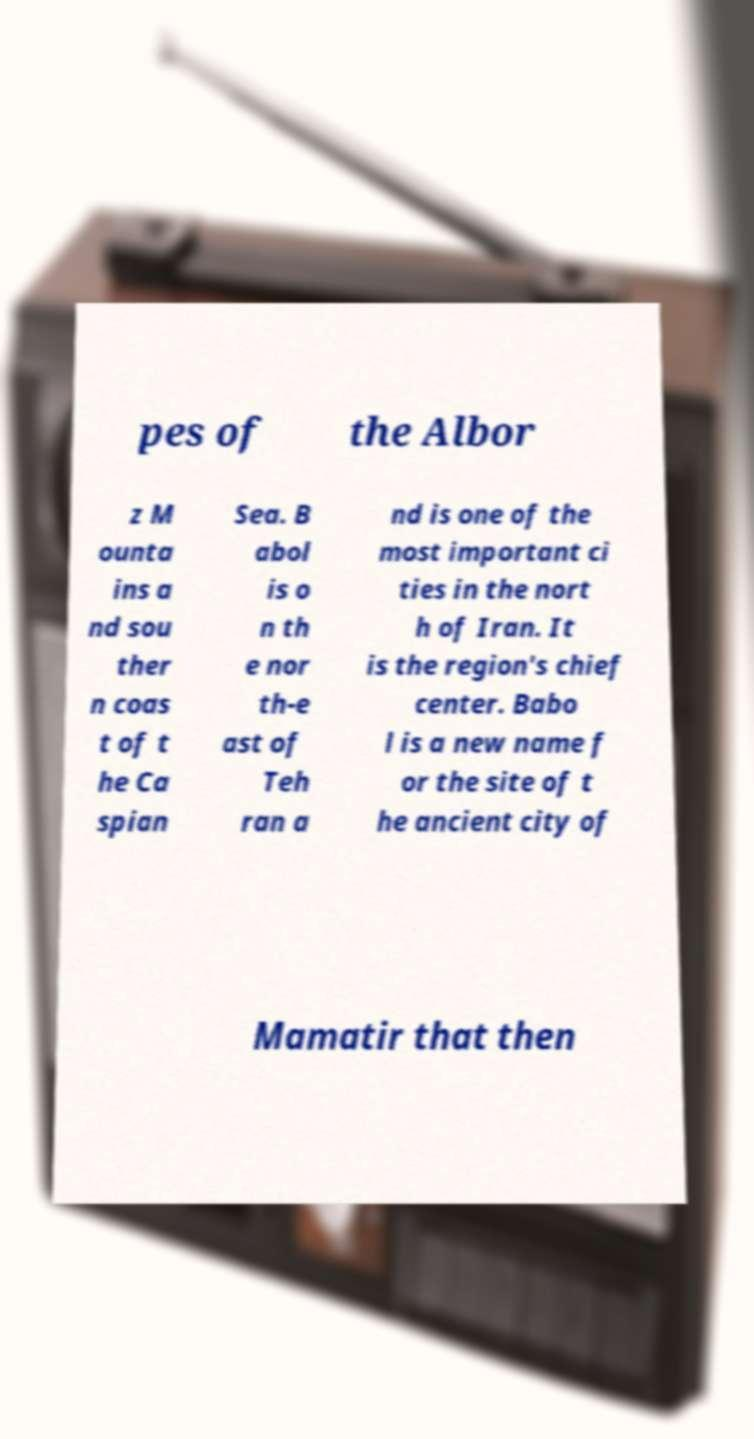Could you extract and type out the text from this image? pes of the Albor z M ounta ins a nd sou ther n coas t of t he Ca spian Sea. B abol is o n th e nor th-e ast of Teh ran a nd is one of the most important ci ties in the nort h of Iran. It is the region's chief center. Babo l is a new name f or the site of t he ancient city of Mamatir that then 